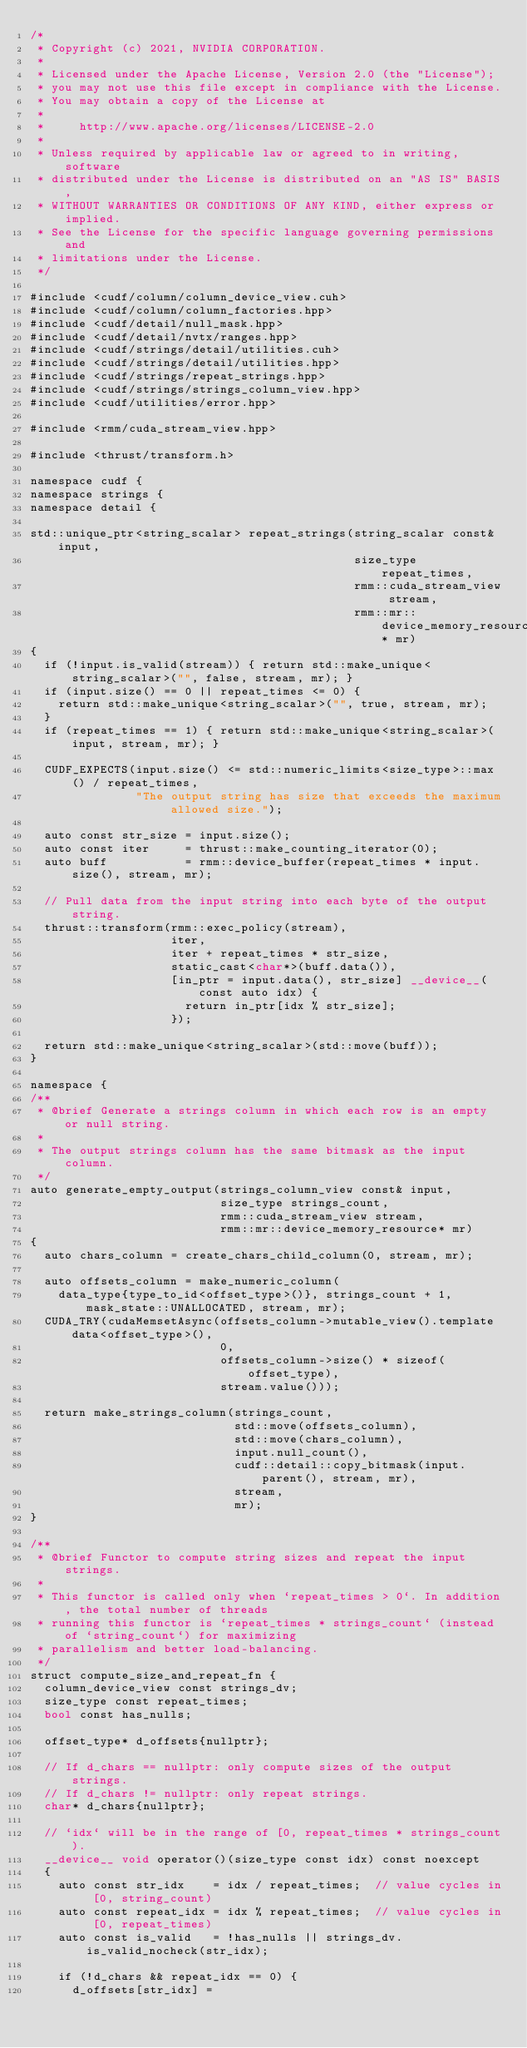Convert code to text. <code><loc_0><loc_0><loc_500><loc_500><_Cuda_>/*
 * Copyright (c) 2021, NVIDIA CORPORATION.
 *
 * Licensed under the Apache License, Version 2.0 (the "License");
 * you may not use this file except in compliance with the License.
 * You may obtain a copy of the License at
 *
 *     http://www.apache.org/licenses/LICENSE-2.0
 *
 * Unless required by applicable law or agreed to in writing, software
 * distributed under the License is distributed on an "AS IS" BASIS,
 * WITHOUT WARRANTIES OR CONDITIONS OF ANY KIND, either express or implied.
 * See the License for the specific language governing permissions and
 * limitations under the License.
 */

#include <cudf/column/column_device_view.cuh>
#include <cudf/column/column_factories.hpp>
#include <cudf/detail/null_mask.hpp>
#include <cudf/detail/nvtx/ranges.hpp>
#include <cudf/strings/detail/utilities.cuh>
#include <cudf/strings/detail/utilities.hpp>
#include <cudf/strings/repeat_strings.hpp>
#include <cudf/strings/strings_column_view.hpp>
#include <cudf/utilities/error.hpp>

#include <rmm/cuda_stream_view.hpp>

#include <thrust/transform.h>

namespace cudf {
namespace strings {
namespace detail {

std::unique_ptr<string_scalar> repeat_strings(string_scalar const& input,
                                              size_type repeat_times,
                                              rmm::cuda_stream_view stream,
                                              rmm::mr::device_memory_resource* mr)
{
  if (!input.is_valid(stream)) { return std::make_unique<string_scalar>("", false, stream, mr); }
  if (input.size() == 0 || repeat_times <= 0) {
    return std::make_unique<string_scalar>("", true, stream, mr);
  }
  if (repeat_times == 1) { return std::make_unique<string_scalar>(input, stream, mr); }

  CUDF_EXPECTS(input.size() <= std::numeric_limits<size_type>::max() / repeat_times,
               "The output string has size that exceeds the maximum allowed size.");

  auto const str_size = input.size();
  auto const iter     = thrust::make_counting_iterator(0);
  auto buff           = rmm::device_buffer(repeat_times * input.size(), stream, mr);

  // Pull data from the input string into each byte of the output string.
  thrust::transform(rmm::exec_policy(stream),
                    iter,
                    iter + repeat_times * str_size,
                    static_cast<char*>(buff.data()),
                    [in_ptr = input.data(), str_size] __device__(const auto idx) {
                      return in_ptr[idx % str_size];
                    });

  return std::make_unique<string_scalar>(std::move(buff));
}

namespace {
/**
 * @brief Generate a strings column in which each row is an empty or null string.
 *
 * The output strings column has the same bitmask as the input column.
 */
auto generate_empty_output(strings_column_view const& input,
                           size_type strings_count,
                           rmm::cuda_stream_view stream,
                           rmm::mr::device_memory_resource* mr)
{
  auto chars_column = create_chars_child_column(0, stream, mr);

  auto offsets_column = make_numeric_column(
    data_type{type_to_id<offset_type>()}, strings_count + 1, mask_state::UNALLOCATED, stream, mr);
  CUDA_TRY(cudaMemsetAsync(offsets_column->mutable_view().template data<offset_type>(),
                           0,
                           offsets_column->size() * sizeof(offset_type),
                           stream.value()));

  return make_strings_column(strings_count,
                             std::move(offsets_column),
                             std::move(chars_column),
                             input.null_count(),
                             cudf::detail::copy_bitmask(input.parent(), stream, mr),
                             stream,
                             mr);
}

/**
 * @brief Functor to compute string sizes and repeat the input strings.
 *
 * This functor is called only when `repeat_times > 0`. In addition, the total number of threads
 * running this functor is `repeat_times * strings_count` (instead of `string_count`) for maximizing
 * parallelism and better load-balancing.
 */
struct compute_size_and_repeat_fn {
  column_device_view const strings_dv;
  size_type const repeat_times;
  bool const has_nulls;

  offset_type* d_offsets{nullptr};

  // If d_chars == nullptr: only compute sizes of the output strings.
  // If d_chars != nullptr: only repeat strings.
  char* d_chars{nullptr};

  // `idx` will be in the range of [0, repeat_times * strings_count).
  __device__ void operator()(size_type const idx) const noexcept
  {
    auto const str_idx    = idx / repeat_times;  // value cycles in [0, string_count)
    auto const repeat_idx = idx % repeat_times;  // value cycles in [0, repeat_times)
    auto const is_valid   = !has_nulls || strings_dv.is_valid_nocheck(str_idx);

    if (!d_chars && repeat_idx == 0) {
      d_offsets[str_idx] =</code> 